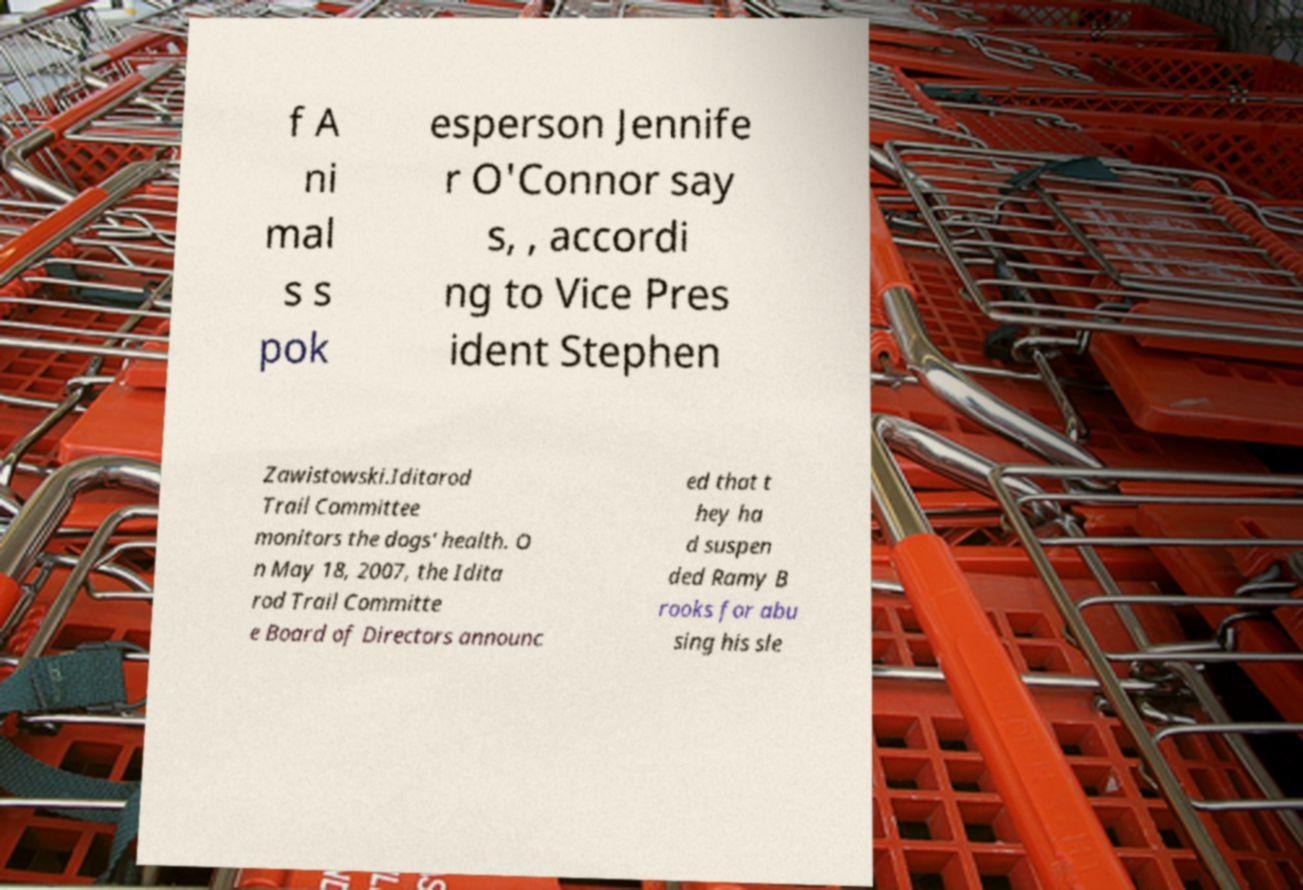Can you read and provide the text displayed in the image?This photo seems to have some interesting text. Can you extract and type it out for me? f A ni mal s s pok esperson Jennife r O'Connor say s, , accordi ng to Vice Pres ident Stephen Zawistowski.Iditarod Trail Committee monitors the dogs' health. O n May 18, 2007, the Idita rod Trail Committe e Board of Directors announc ed that t hey ha d suspen ded Ramy B rooks for abu sing his sle 